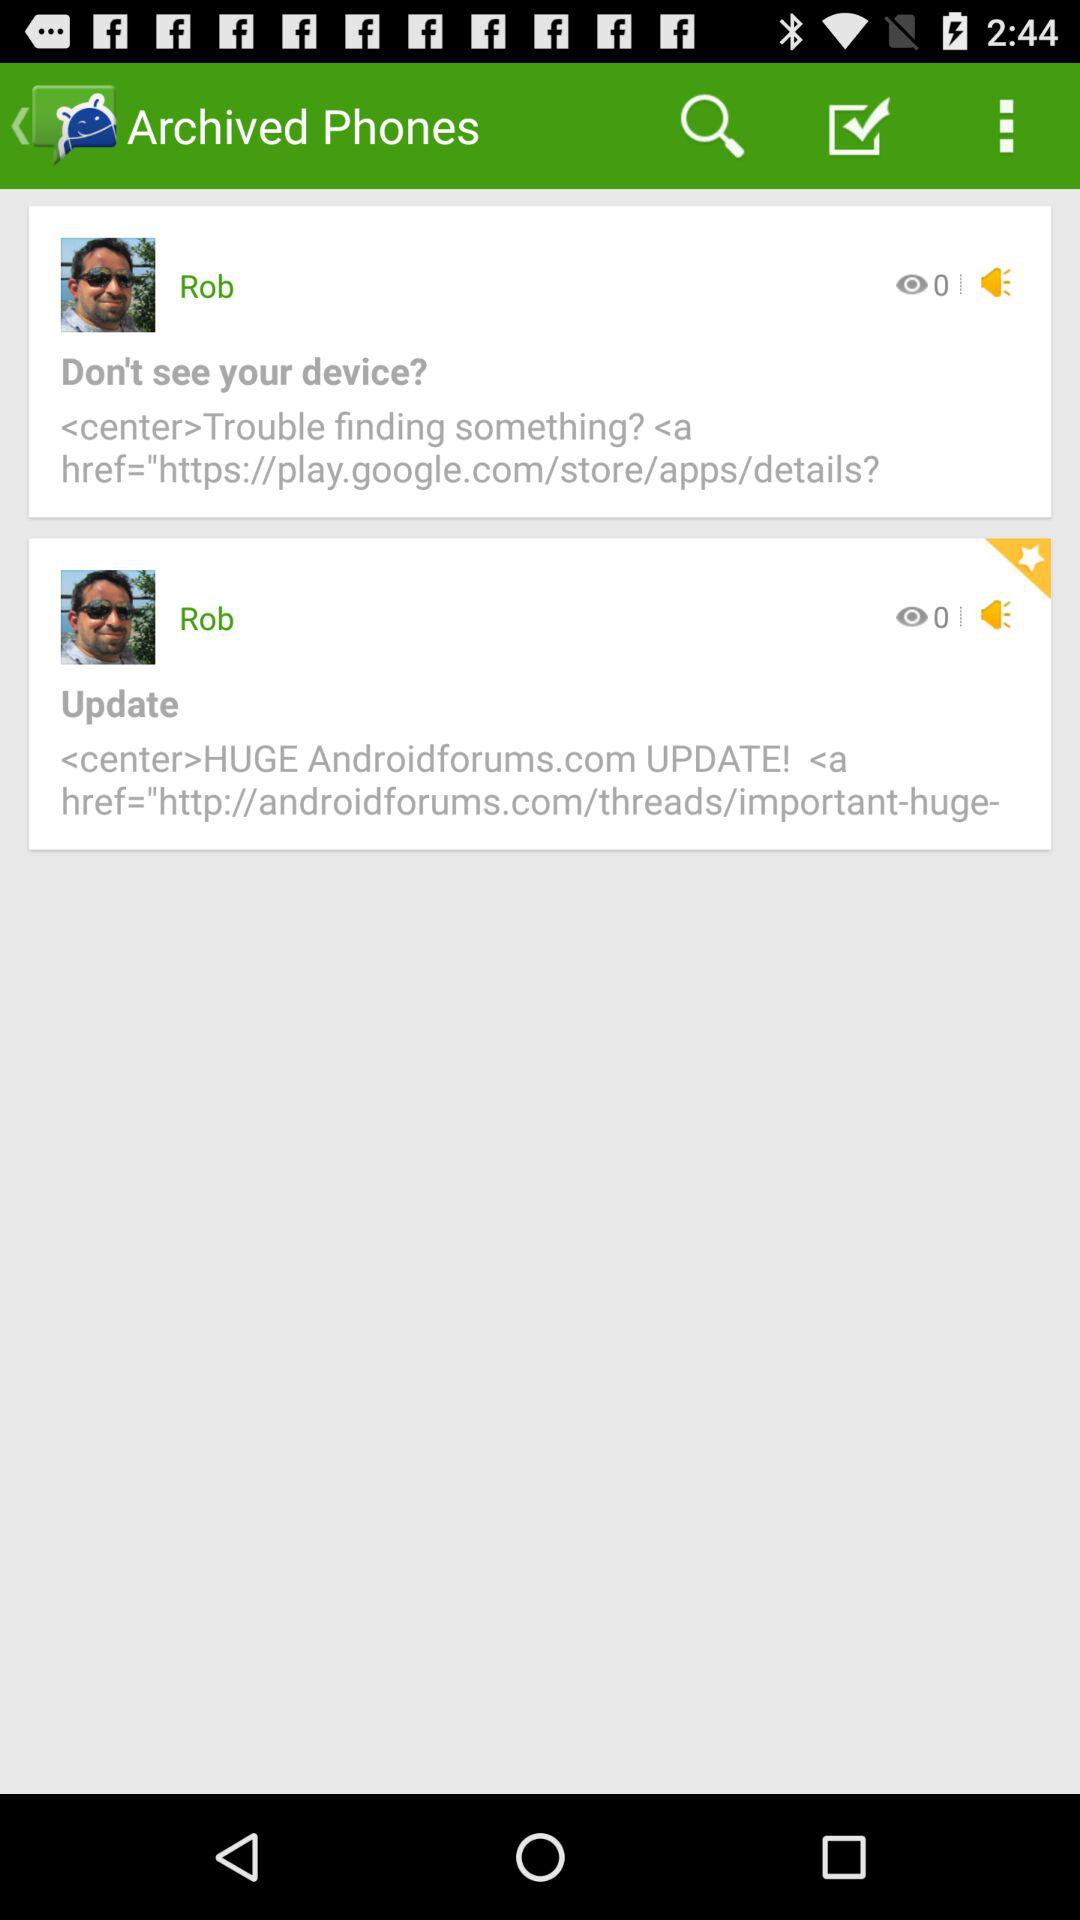What is the name of the user? The name of the user is Rob. 